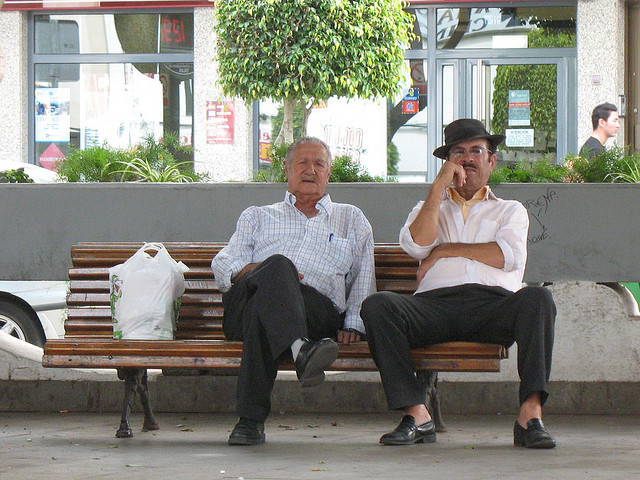Extract all visible text content from this image. A 